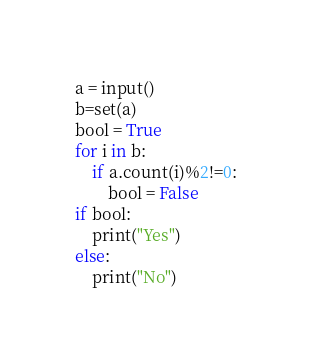<code> <loc_0><loc_0><loc_500><loc_500><_Python_>a = input()
b=set(a)
bool = True
for i in b:
    if a.count(i)%2!=0:
        bool = False
if bool:
    print("Yes")
else:
    print("No")</code> 